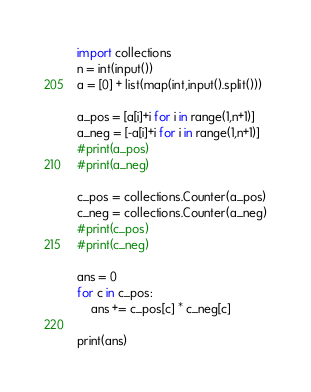Convert code to text. <code><loc_0><loc_0><loc_500><loc_500><_Python_>import collections
n = int(input())
a = [0] + list(map(int,input().split()))

a_pos = [a[i]+i for i in range(1,n+1)]
a_neg = [-a[i]+i for i in range(1,n+1)]
#print(a_pos)
#print(a_neg)

c_pos = collections.Counter(a_pos)
c_neg = collections.Counter(a_neg)
#print(c_pos)
#print(c_neg)

ans = 0
for c in c_pos:
    ans += c_pos[c] * c_neg[c]

print(ans)</code> 